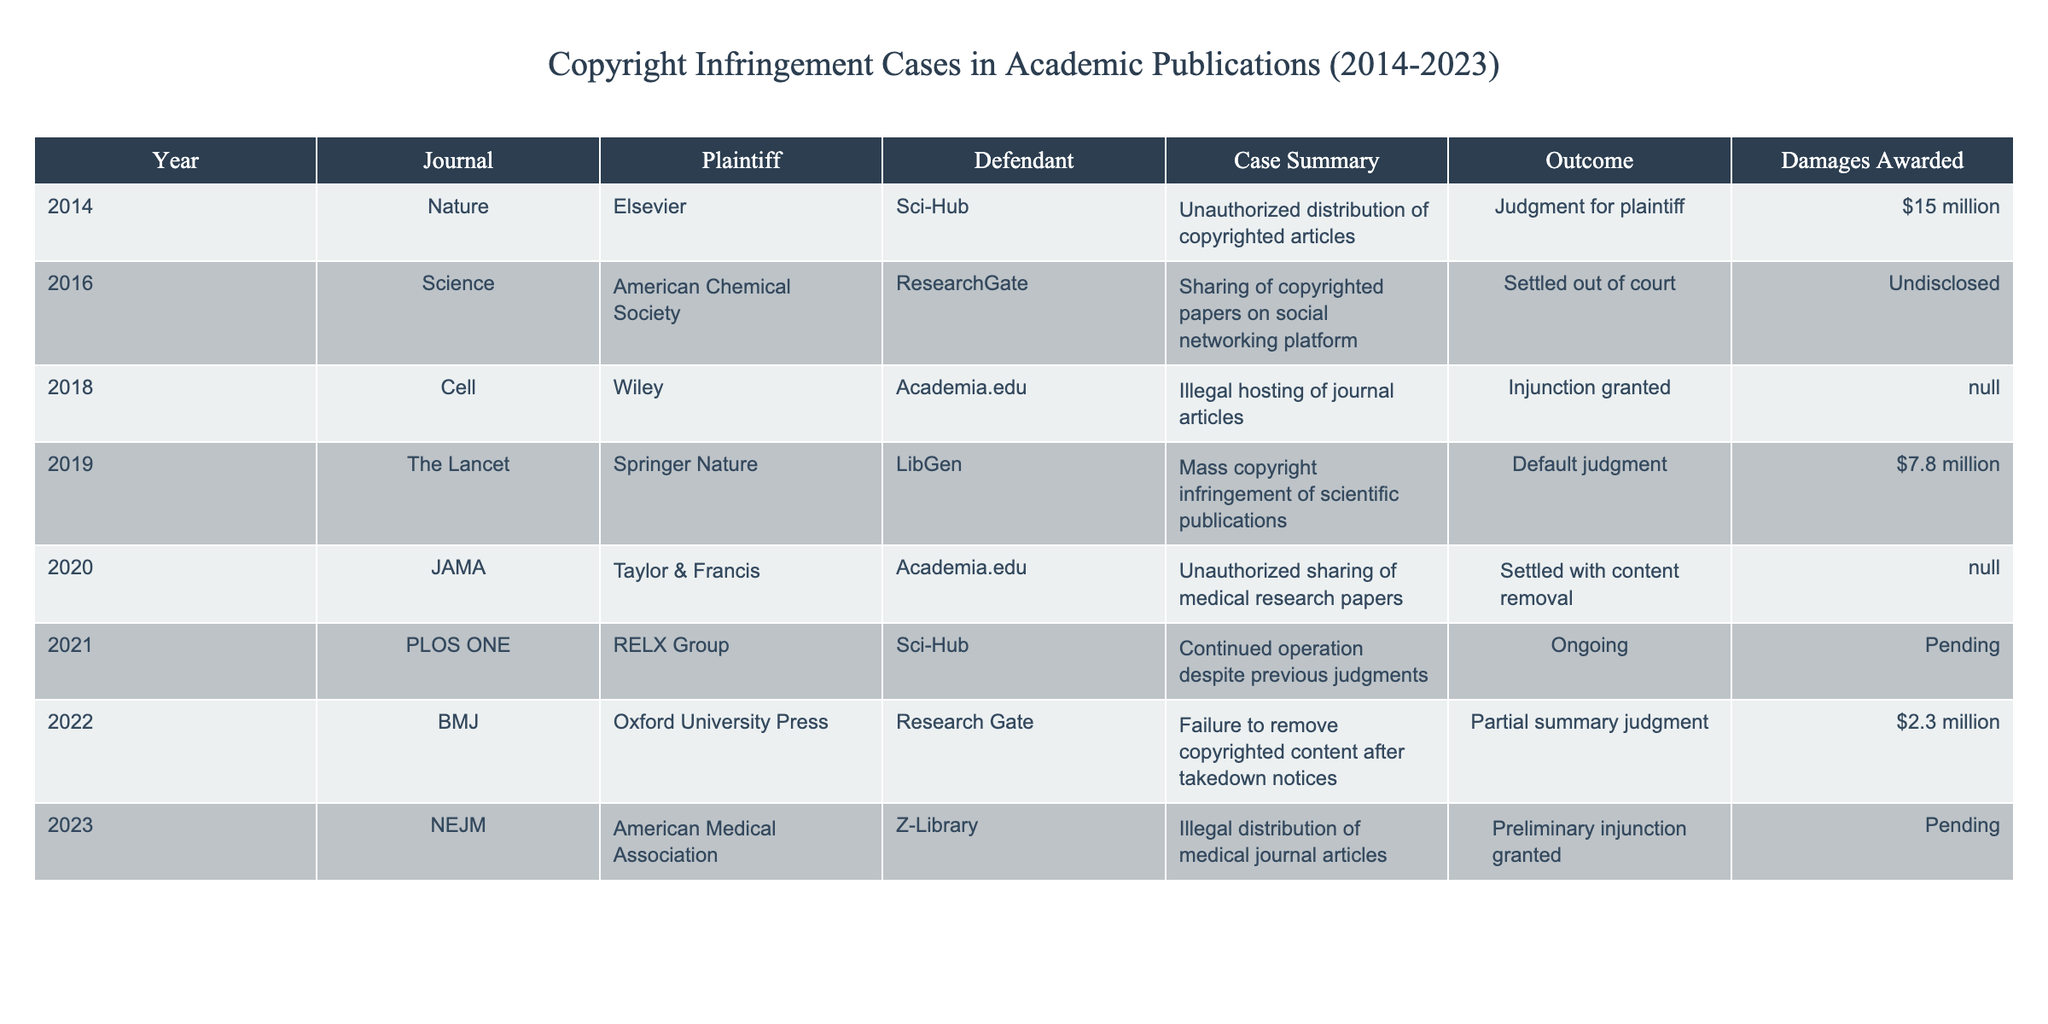What year did the case involving Sci-Hub and Elsevier occur? The table indicates that the case involving Sci-Hub and Elsevier occurred in 2014, as listed under the "Year" column for the corresponding row.
Answer: 2014 Which journal had a case settled out of court in 2016? According to the table, the journal that had a case settled out of court in 2016 is Science, as seen in the corresponding row under the "Journal" column.
Answer: Science What was the total damages awarded in the cases listed for 2014 and 2019? To find the total damages for 2014 and 2019, we add the amounts: $15 million (2014) + $7.8 million (2019) = $22.8 million.
Answer: $22.8 million Is there an ongoing case involving Sci-Hub? Yes, the table shows that there is an ongoing case involving Sci-Hub, noted in the "Outcome" column as "Ongoing" for the year 2021.
Answer: Yes In which year did the highest damages awarded occur? Reviewing the "Damages Awarded" column, the highest amount awarded is $15 million in 2014, as indicated in the table.
Answer: 2014 What percentage of cases resulted in a judgment for the plaintiff? There are 8 cases in total. The cases with a judgment for the plaintiff are 2014 (Elsevier vs. Sci-Hub) and 2019 (Springer Nature vs. LibGen), totaling 2 cases. The percentage is (2/8) * 100 = 25%.
Answer: 25% Which journal was involved in the case that resulted in a preliminary injunction in 2023? The table shows that the journal involved in the case resulting in a preliminary injunction in 2023 is NEJM, as noted in the "Journal" column for that year.
Answer: NEJM How many cases mentioned "Settled" as the outcome? In the table, there are two cases where the outcome is listed as "Settled", those in 2016 and 2020.
Answer: 2 What was the average damages awarded for all cases except those marked as "N/A"? The damages awarded for the cases with specific values are: $15 million, $7.8 million, $2.3 million. The average is calculated as: ($15 million + $7.8 million + $2.3 million) / 3 = $8.366 million.
Answer: $8.366 million Which defendant was associated with the illegal hosting of journal articles? The table specifies that Academia.edu was the defendant associated with the case concerning illegal hosting of journal articles in 2018 under the summary for the "Cell" journal.
Answer: Academia.edu 